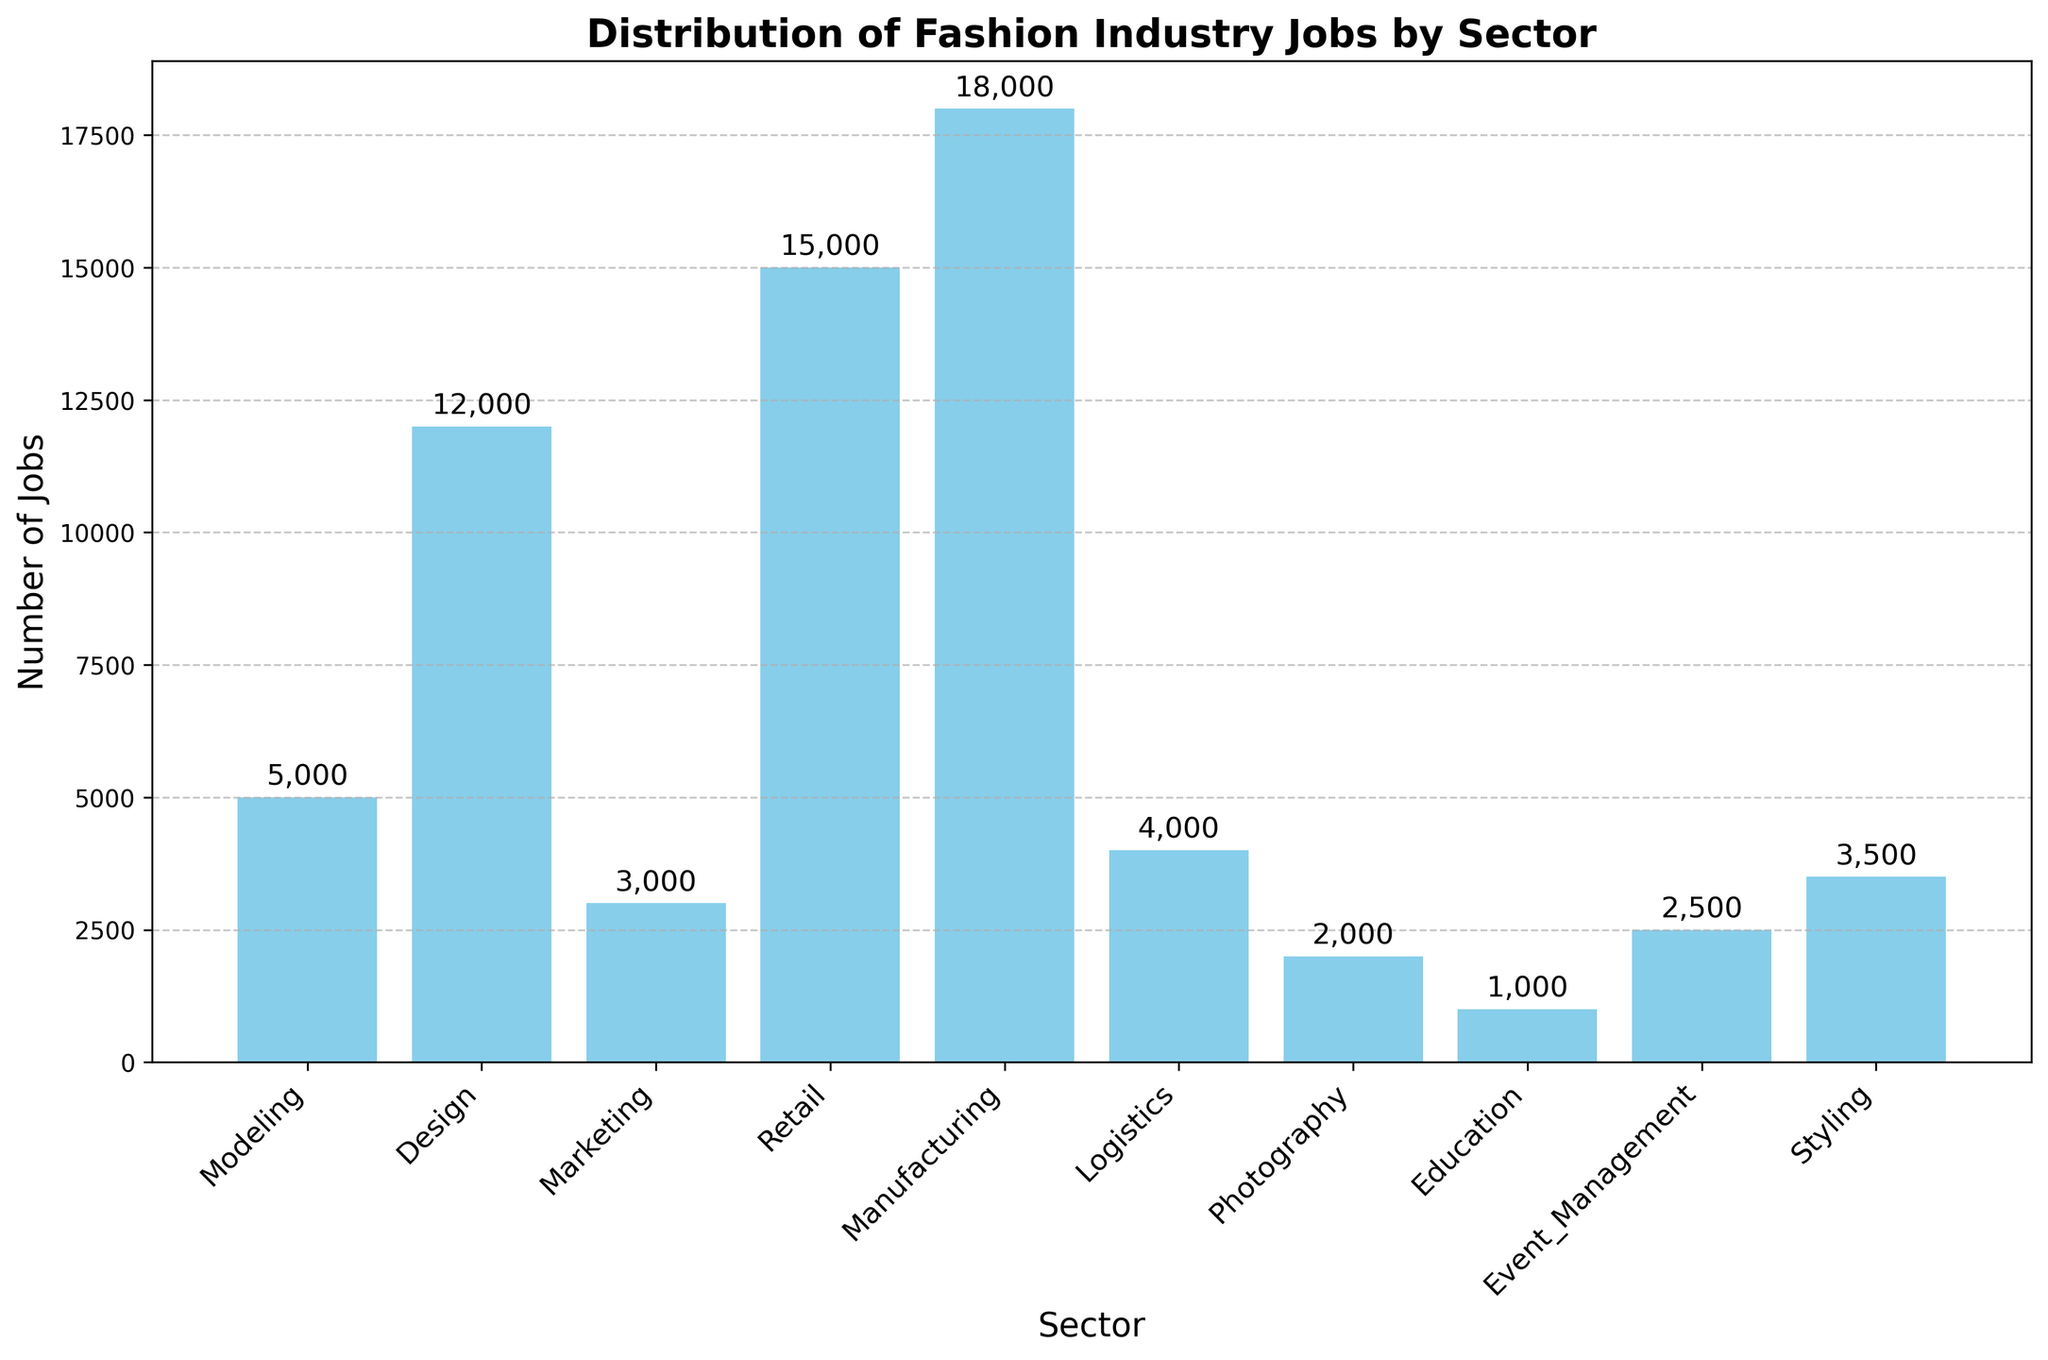What's the sector with the highest number of jobs? The tallest bar represents the sector with the highest number of jobs. The Manufacturing sector has the highest bar.
Answer: Manufacturing Which sector has fewer jobs, Modeling or Photography? The height of the bars for Modeling and Photography needs to be compared. The bar for Photography is smaller.
Answer: Photography What is the total number of jobs in Design and Marketing? Sum the number of jobs in Design and Marketing: 12,000 + 3,000.
Answer: 15,000 How many more jobs are there in Retail than in Event Management? Subtract the number of jobs in Event Management from Retail: 15,000 - 2,500.
Answer: 12,500 What is the average number of jobs across all sectors? Add the number of jobs across all sectors and divide by the number of sectors. (50,000 / 10).
Answer: 5,000 Which sector has the least number of jobs? The shortest bar corresponds to the sector with the least number of jobs. The Education sector has the shortest bar.
Answer: Education How many jobs are there in sectors other than Retail and Manufacturing combined? Subtract the jobs in Retail and Manufacturing from the total number of jobs: 50,000 - (15,000 + 18,000).
Answer: 17,000 Which sectors have fewer jobs than Logistics? Compare the height of the bars for each sector against the Logistics sector. Education, Photography, Marketing, and Event Management have fewer jobs than Logistics.
Answer: Education, Photography, Marketing, Event Management Are there more jobs in Modeling or in Styling? Compare the height of the bars for both Modeling and Styling. The Styling bar is taller.
Answer: Styling What proportion of jobs are in the Retail sector compared to the total? Divide the number of jobs in Retail by the total number of jobs: 15,000 / 50,000.
Answer: 0.3 